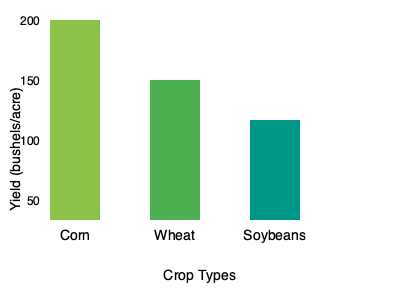As a modern farmer, you're analyzing crop yields to optimize your farm's production. Based on the bar graph showing yields for corn, wheat, and soybeans, what is the difference in bushels per acre between the highest and lowest yielding crops? To find the difference between the highest and lowest yielding crops, we need to:

1. Identify the highest yielding crop:
   Corn has the tallest bar, reaching 200 bushels/acre.

2. Identify the lowest yielding crop:
   Soybeans has the shortest bar, reaching 100 bushels/acre.

3. Calculate the difference:
   $200 - 100 = 100$ bushels/acre

This difference represents the yield gap between corn and soybeans, which is crucial information for a modern farmer when deciding crop allocation and potential areas for yield improvement.
Answer: 100 bushels/acre 